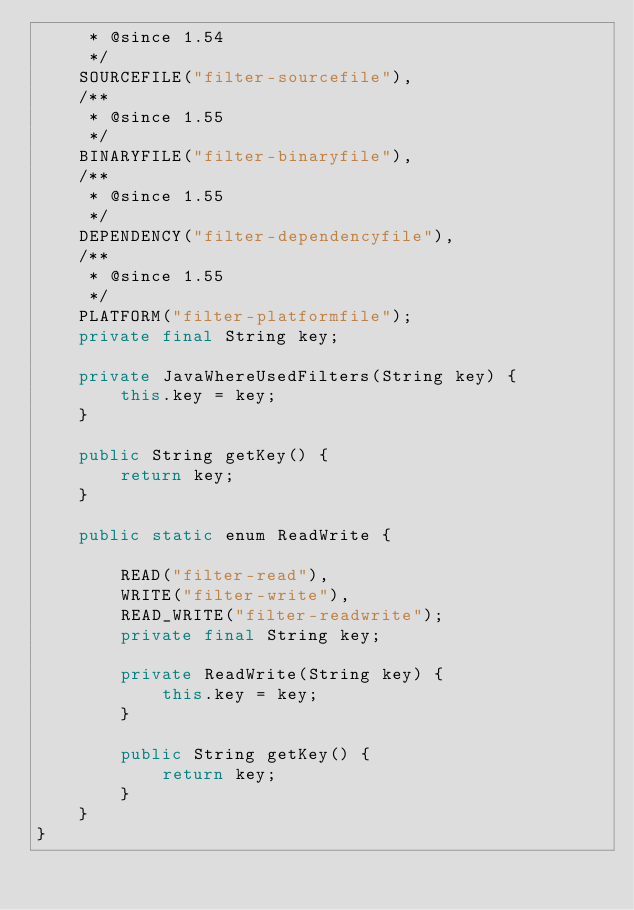<code> <loc_0><loc_0><loc_500><loc_500><_Java_>     * @since 1.54
     */
    SOURCEFILE("filter-sourcefile"),
    /**
     * @since 1.55
     */
    BINARYFILE("filter-binaryfile"),
    /**
     * @since 1.55
     */
    DEPENDENCY("filter-dependencyfile"),
    /**
     * @since 1.55
     */
    PLATFORM("filter-platformfile");
    private final String key;

    private JavaWhereUsedFilters(String key) {
        this.key = key;
    }

    public String getKey() {
        return key;
    }

    public static enum ReadWrite {

        READ("filter-read"),
        WRITE("filter-write"),
        READ_WRITE("filter-readwrite");
        private final String key;

        private ReadWrite(String key) {
            this.key = key;
        }

        public String getKey() {
            return key;
        }
    }
}</code> 